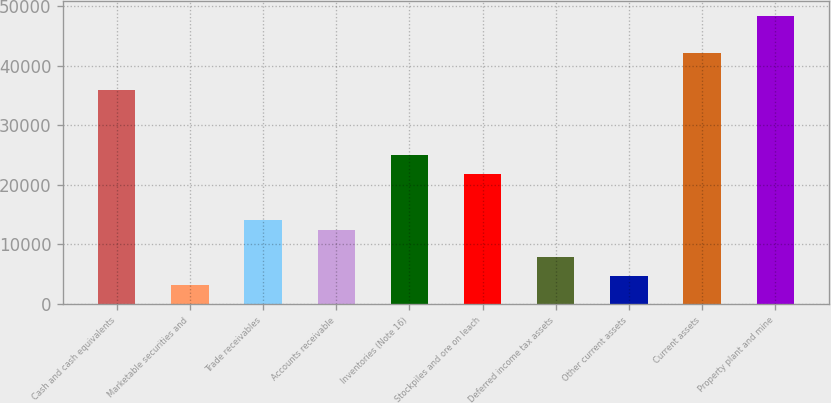Convert chart to OTSL. <chart><loc_0><loc_0><loc_500><loc_500><bar_chart><fcel>Cash and cash equivalents<fcel>Marketable securities and<fcel>Trade receivables<fcel>Accounts receivable<fcel>Inventories (Note 16)<fcel>Stockpiles and ore on leach<fcel>Deferred income tax assets<fcel>Other current assets<fcel>Current assets<fcel>Property plant and mine<nl><fcel>35871.5<fcel>3122<fcel>14038.5<fcel>12479<fcel>24955<fcel>21836<fcel>7800.5<fcel>4681.5<fcel>42109.5<fcel>48347.5<nl></chart> 